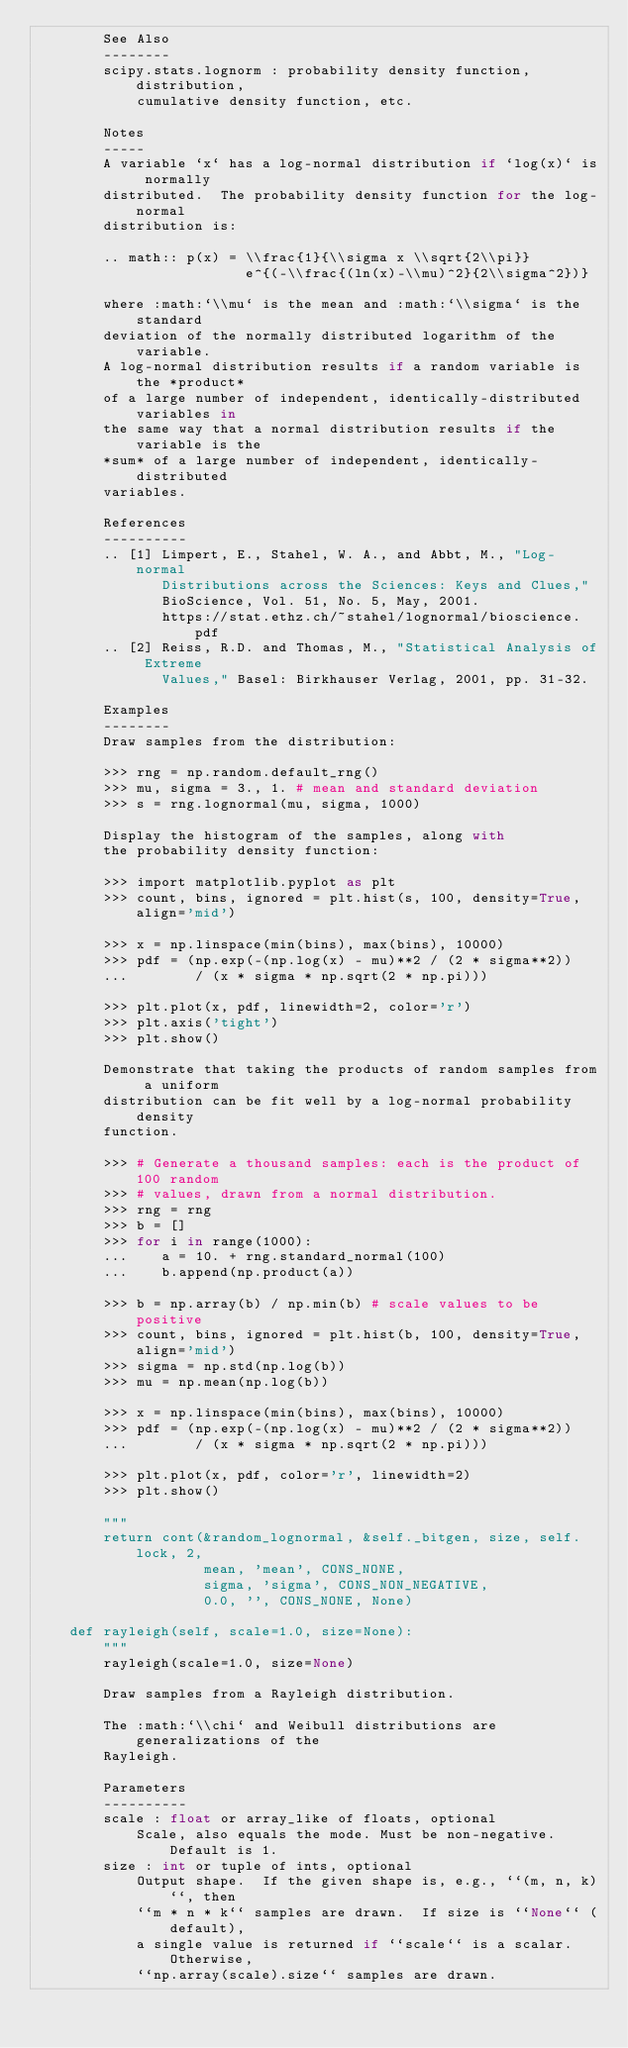<code> <loc_0><loc_0><loc_500><loc_500><_Cython_>        See Also
        --------
        scipy.stats.lognorm : probability density function, distribution,
            cumulative density function, etc.

        Notes
        -----
        A variable `x` has a log-normal distribution if `log(x)` is normally
        distributed.  The probability density function for the log-normal
        distribution is:

        .. math:: p(x) = \\frac{1}{\\sigma x \\sqrt{2\\pi}}
                         e^{(-\\frac{(ln(x)-\\mu)^2}{2\\sigma^2})}

        where :math:`\\mu` is the mean and :math:`\\sigma` is the standard
        deviation of the normally distributed logarithm of the variable.
        A log-normal distribution results if a random variable is the *product*
        of a large number of independent, identically-distributed variables in
        the same way that a normal distribution results if the variable is the
        *sum* of a large number of independent, identically-distributed
        variables.

        References
        ----------
        .. [1] Limpert, E., Stahel, W. A., and Abbt, M., "Log-normal
               Distributions across the Sciences: Keys and Clues,"
               BioScience, Vol. 51, No. 5, May, 2001.
               https://stat.ethz.ch/~stahel/lognormal/bioscience.pdf
        .. [2] Reiss, R.D. and Thomas, M., "Statistical Analysis of Extreme
               Values," Basel: Birkhauser Verlag, 2001, pp. 31-32.

        Examples
        --------
        Draw samples from the distribution:

        >>> rng = np.random.default_rng()
        >>> mu, sigma = 3., 1. # mean and standard deviation
        >>> s = rng.lognormal(mu, sigma, 1000)

        Display the histogram of the samples, along with
        the probability density function:

        >>> import matplotlib.pyplot as plt
        >>> count, bins, ignored = plt.hist(s, 100, density=True, align='mid')

        >>> x = np.linspace(min(bins), max(bins), 10000)
        >>> pdf = (np.exp(-(np.log(x) - mu)**2 / (2 * sigma**2))
        ...        / (x * sigma * np.sqrt(2 * np.pi)))

        >>> plt.plot(x, pdf, linewidth=2, color='r')
        >>> plt.axis('tight')
        >>> plt.show()

        Demonstrate that taking the products of random samples from a uniform
        distribution can be fit well by a log-normal probability density
        function.

        >>> # Generate a thousand samples: each is the product of 100 random
        >>> # values, drawn from a normal distribution.
        >>> rng = rng
        >>> b = []
        >>> for i in range(1000):
        ...    a = 10. + rng.standard_normal(100)
        ...    b.append(np.product(a))

        >>> b = np.array(b) / np.min(b) # scale values to be positive
        >>> count, bins, ignored = plt.hist(b, 100, density=True, align='mid')
        >>> sigma = np.std(np.log(b))
        >>> mu = np.mean(np.log(b))

        >>> x = np.linspace(min(bins), max(bins), 10000)
        >>> pdf = (np.exp(-(np.log(x) - mu)**2 / (2 * sigma**2))
        ...        / (x * sigma * np.sqrt(2 * np.pi)))

        >>> plt.plot(x, pdf, color='r', linewidth=2)
        >>> plt.show()

        """
        return cont(&random_lognormal, &self._bitgen, size, self.lock, 2,
                    mean, 'mean', CONS_NONE,
                    sigma, 'sigma', CONS_NON_NEGATIVE,
                    0.0, '', CONS_NONE, None)

    def rayleigh(self, scale=1.0, size=None):
        """
        rayleigh(scale=1.0, size=None)

        Draw samples from a Rayleigh distribution.

        The :math:`\\chi` and Weibull distributions are generalizations of the
        Rayleigh.

        Parameters
        ----------
        scale : float or array_like of floats, optional
            Scale, also equals the mode. Must be non-negative. Default is 1.
        size : int or tuple of ints, optional
            Output shape.  If the given shape is, e.g., ``(m, n, k)``, then
            ``m * n * k`` samples are drawn.  If size is ``None`` (default),
            a single value is returned if ``scale`` is a scalar.  Otherwise,
            ``np.array(scale).size`` samples are drawn.
</code> 